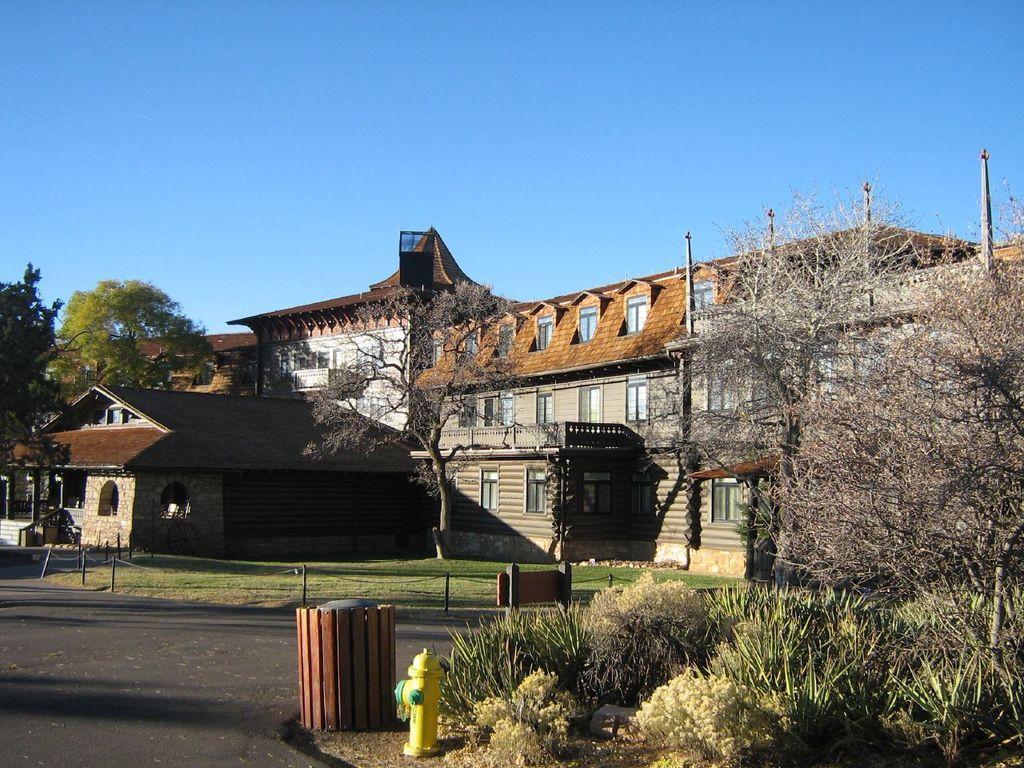Describe this image in one or two sentences. This looks like a building with the windows. I can see a fire hydrant. These are the trees and bushes. This looks like a board, which is attached to the poles. I think this is a dustbin. Here is the grass. This is the sky. 